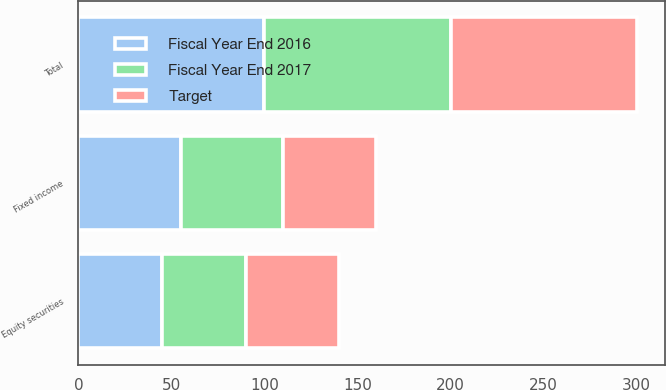Convert chart to OTSL. <chart><loc_0><loc_0><loc_500><loc_500><stacked_bar_chart><ecel><fcel>Equity securities<fcel>Fixed income<fcel>Total<nl><fcel>Fiscal Year End 2017<fcel>45<fcel>55<fcel>100<nl><fcel>Target<fcel>50<fcel>50<fcel>100<nl><fcel>Fiscal Year End 2016<fcel>45<fcel>55<fcel>100<nl></chart> 